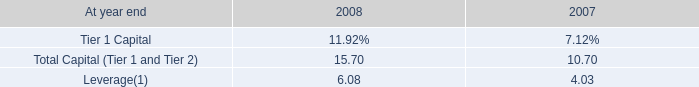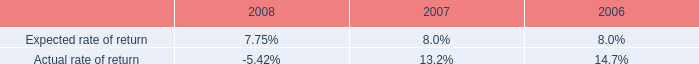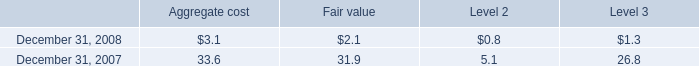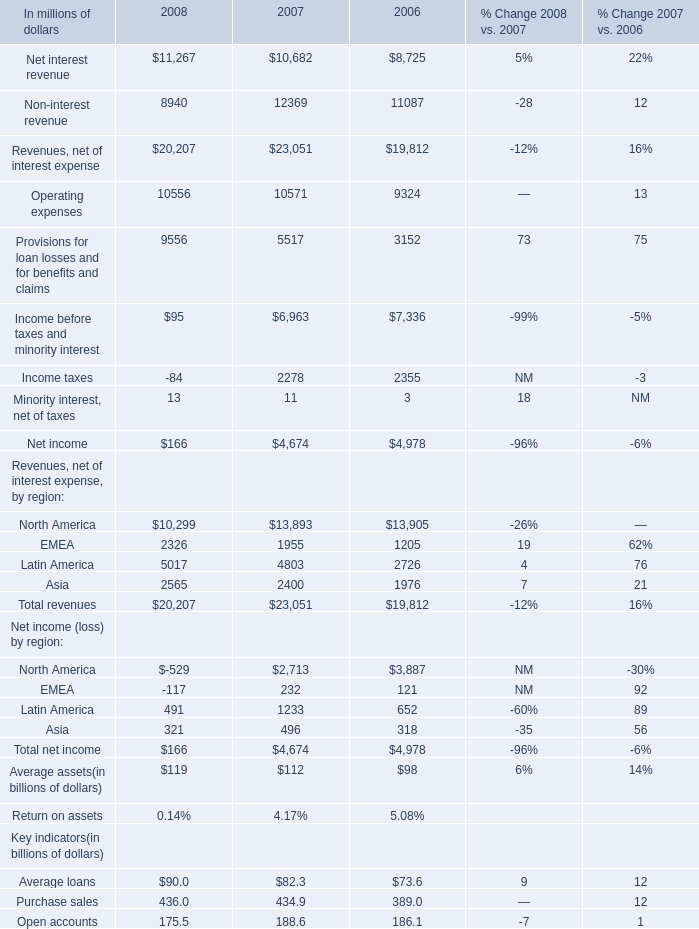what was the percentage discount given in the reset of convertible preferred stock issued in the private offering ? 
Computations: ((31.62 - 26.35) / 31.62)
Answer: 0.16667. 